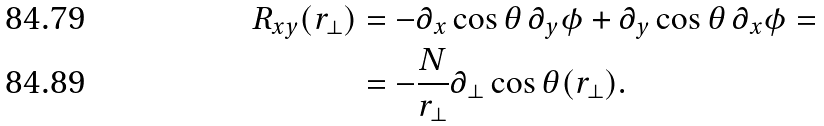Convert formula to latex. <formula><loc_0><loc_0><loc_500><loc_500>R _ { x y } ( r _ { \perp } ) & = - \partial _ { x } \cos \theta \, \partial _ { y } \phi + \partial _ { y } \cos \theta \, \partial _ { x } \phi = \\ & = - \frac { N } { r _ { \perp } } \partial _ { \perp } \cos \theta ( r _ { \perp } ) .</formula> 